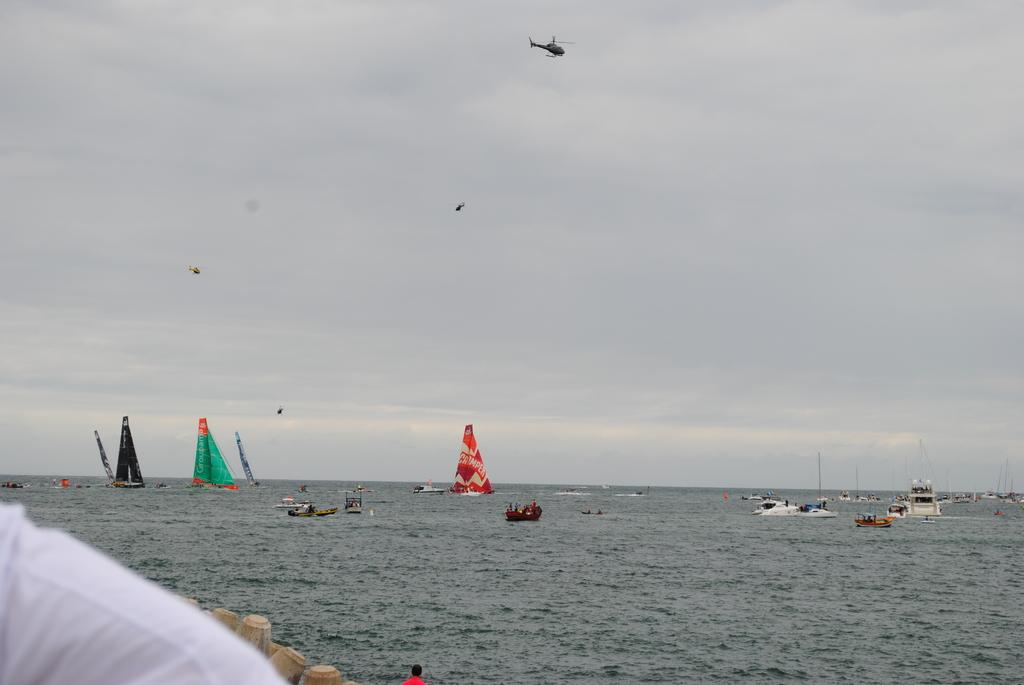What type of vehicles are in the water in the image? There are ships in the water in the image. What are the ships doing in the image? The ships are moving in the water. What is in the sky in the image? There is a helicopter in the sky in the image. What is the helicopter doing in the image? The helicopter is flying in the sky. How many boys are playing on the holiday in the image? There are no boys or holidays mentioned in the image; it features ships in the water and a helicopter in the sky. Can you tell me how many times the helicopter sneezes in the image? There is no indication of the helicopter sneezing in the image; it is simply flying in the sky. 